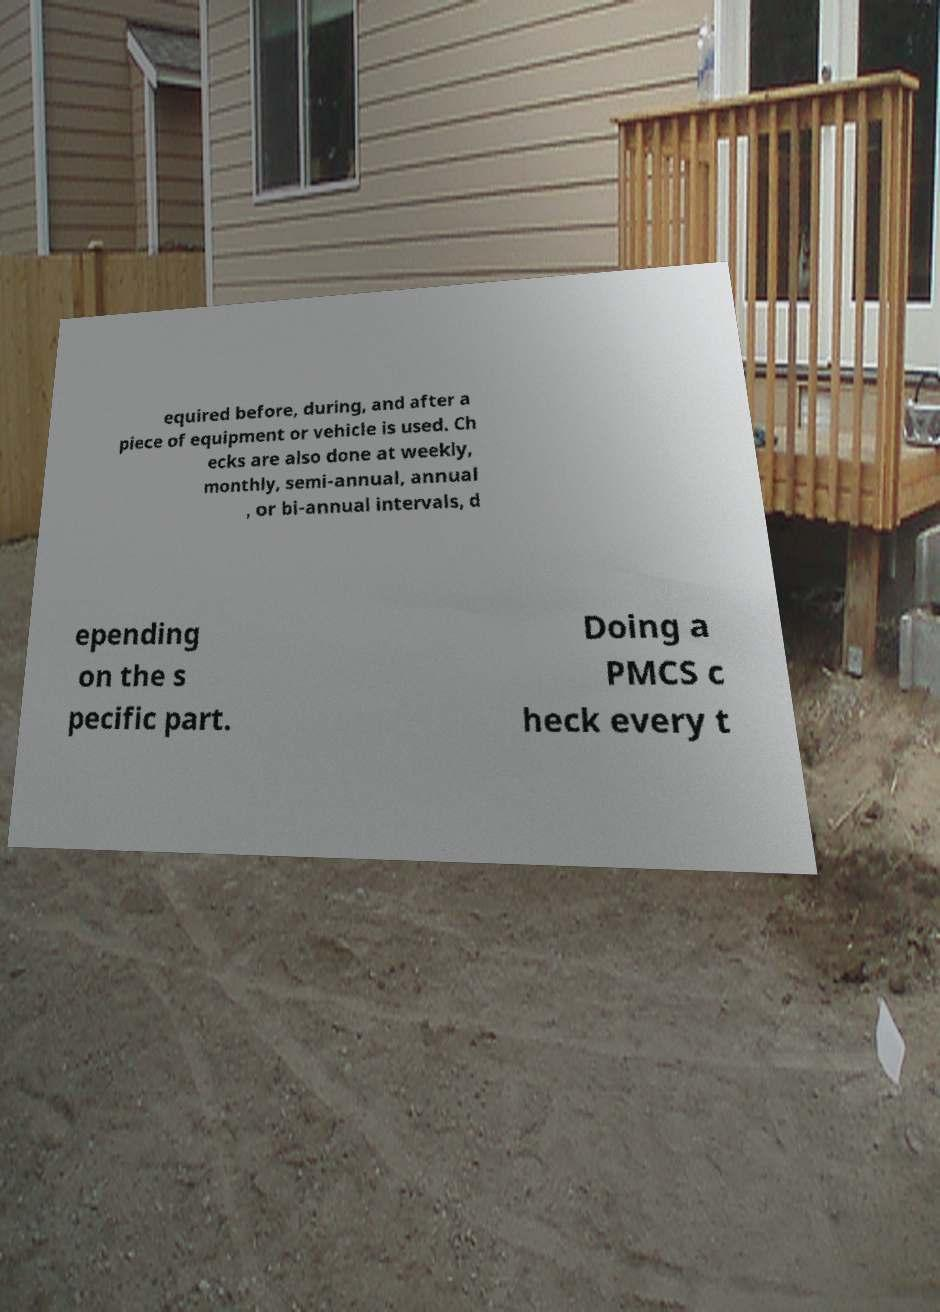Please read and relay the text visible in this image. What does it say? equired before, during, and after a piece of equipment or vehicle is used. Ch ecks are also done at weekly, monthly, semi-annual, annual , or bi-annual intervals, d epending on the s pecific part. Doing a PMCS c heck every t 